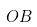Convert formula to latex. <formula><loc_0><loc_0><loc_500><loc_500>O B</formula> 